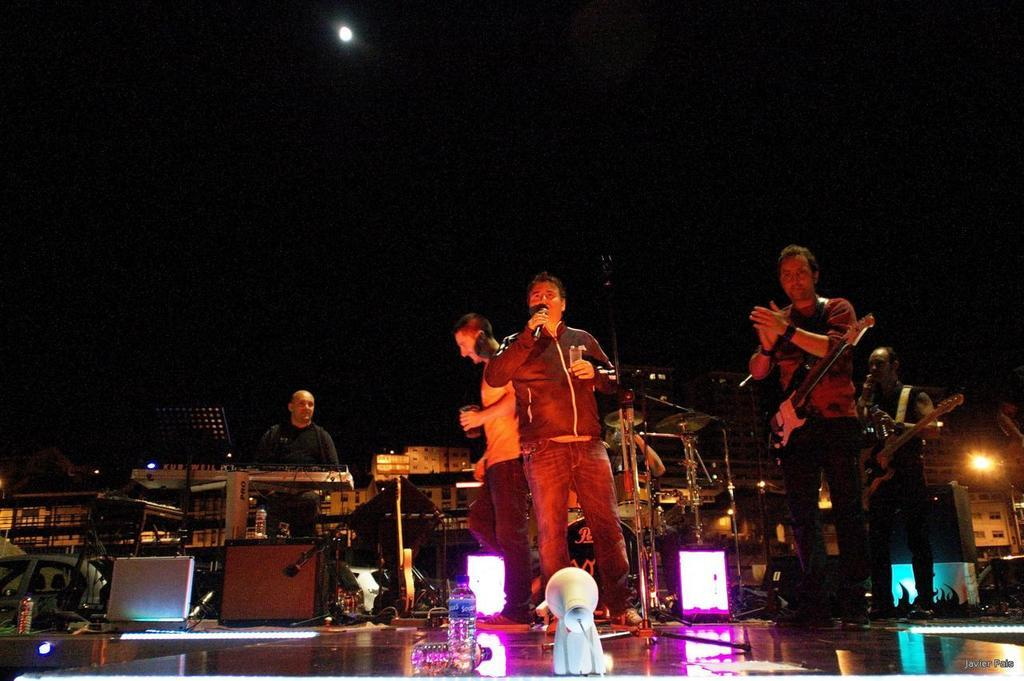What are the people in the image doing? The people in the image are singing. Are the people in the image also involved in any other activities? Yes, some of the people are playing musical instruments. What type of pickle is being passed around among the people in the image? There is no pickle present in the image; the people are singing and playing musical instruments. 